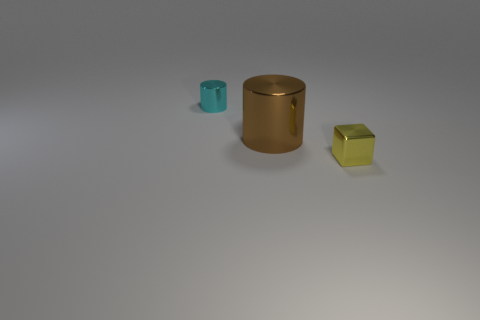How many other things are the same color as the small metallic cylinder?
Offer a terse response. 0. There is a small object in front of the tiny cyan thing; is its shape the same as the shiny object to the left of the large brown metallic object?
Give a very brief answer. No. What number of balls are brown things or tiny yellow objects?
Your answer should be very brief. 0. Is the number of tiny yellow metal things that are on the left side of the large metallic thing less than the number of blue cylinders?
Ensure brevity in your answer.  No. What number of other things are made of the same material as the cyan cylinder?
Make the answer very short. 2. Does the cyan shiny cylinder have the same size as the brown thing?
Your response must be concise. No. How many objects are either small metal things right of the brown metal object or brown cylinders?
Make the answer very short. 2. What material is the cylinder that is right of the object behind the large metal thing?
Ensure brevity in your answer.  Metal. Is there a large purple matte thing that has the same shape as the yellow shiny thing?
Offer a terse response. No. Do the yellow block and the cylinder that is on the right side of the small metallic cylinder have the same size?
Offer a very short reply. No. 